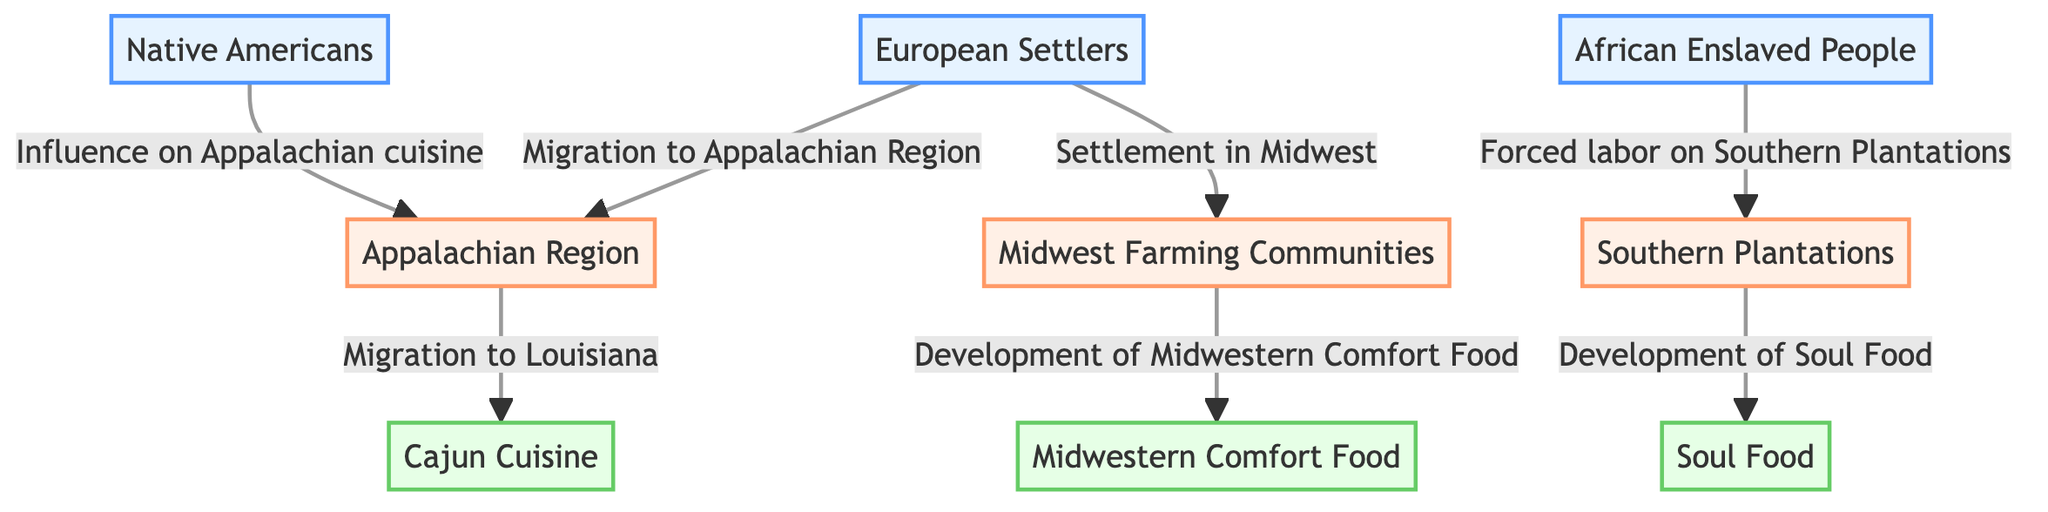What role did European settlers play in food production? European settlers are shown as influencing the Appalachian Region through migration, which implies they contributed to food production there.
Answer: Migration to Appalachian Region How many types of cuisine are represented in the diagram? The diagram lists three types of cuisine: Cajun Cuisine, Soul Food, and Midwestern Comfort Food. Counting these gives a total of three types.
Answer: 3 Which group influenced the development of Soul Food? The diagram indicates that African Enslaved People had a direct influence on the development of Soul Food through their forced labor on Southern Plantations.
Answer: African Enslaved People Where did the Appalachian Region migrants move to? The diagram shows that migrants from the Appalachian Region moved to Louisiana, which is associated with Cajun Cuisine.
Answer: Louisiana What direct connection exists between Native Americans and food production? Native Americans are labeled as having an influence on Appalachian cuisine, indicating a direct connection to food production in that region.
Answer: Influence on Appalachian cuisine What two regions are connected to Southern Plantations? The diagram shows a direct connection from African Enslaved People to Southern Plantations and also notes that these plantations lead to the development of Soul Food. This means Southern Plantations are connected to both African Enslaved People and Soul Food.
Answer: African Enslaved People and Soul Food What is the common theme of the nodes categorized under group 3? The nodes in group 3 all represent types of cuisine that developed as a result of historical migration patterns, specifically reflecting cultural influences in food production.
Answer: Types of cuisine How many nodes are categorized under food production within the diagram? In the diagram, three nodes are categorized under food production, which are Cajun Cuisine, Soul Food, and Midwestern Comfort Food. These directly reflect the impact of historical migration on food.
Answer: 3 